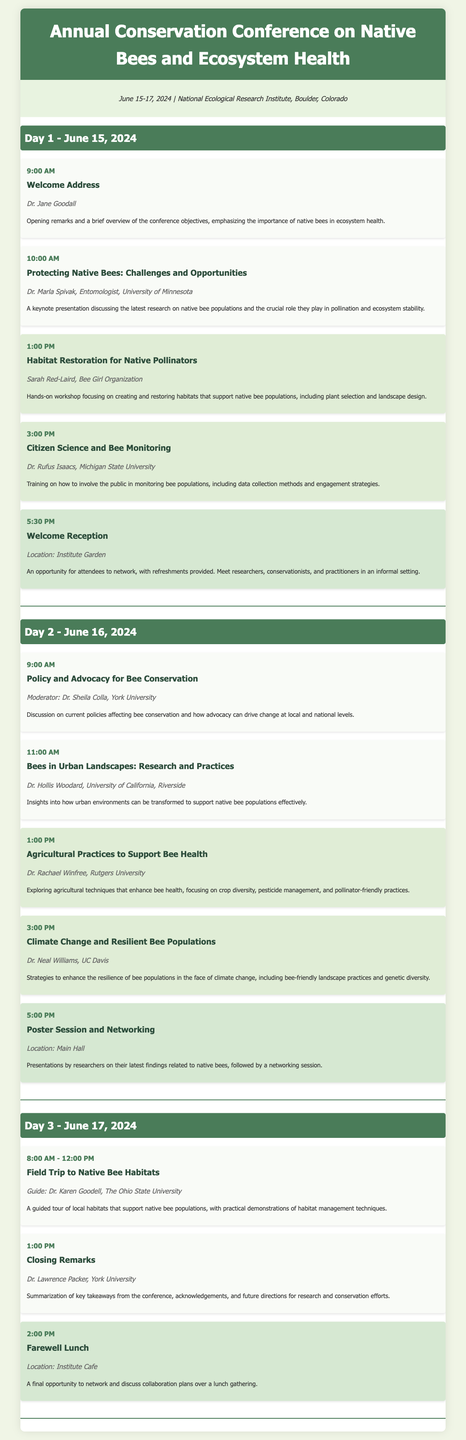What are the dates of the conference? The document explicitly states the dates of the conference in the conference details section.
Answer: June 15-17, 2024 Who is the speaker for the keynote on “Protecting Native Bees: Challenges and Opportunities”? This keynote presentation is listed under Day 1, and the speaker's name is mentioned in the respective event details.
Answer: Dr. Marla Spivak What workshop is scheduled at 1:00 PM on Day 2? The document lists the events for Day 2, including times and titles, allowing identification of the workshop at that specific time.
Answer: Agricultural Practices to Support Bee Health What time does the "Welcome Reception" start? The schedule specifies the start time of this networking event under Day 1.
Answer: 5:30 PM Who leads the field trip on Day 3? The field trip event includes the guide's name in the event description section for Day 3.
Answer: Dr. Karen Goodell Which day features a discussion on policy and advocacy for bee conservation? The schedule indicates event titles for each day, allowing identification of the day featuring this topic.
Answer: Day 2 What is the location for the "Farewell Lunch"? This information is provided in the networking event section for Day 3 where the location is mentioned.
Answer: Institute Cafe How many workshops are scheduled on Day 1? By counting the distinct workshop events listed for Day 1, the total can be determined.
Answer: 2 